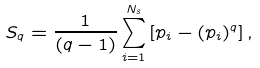<formula> <loc_0><loc_0><loc_500><loc_500>S _ { q } = \frac { 1 } { ( q - 1 ) } \sum _ { i = 1 } ^ { N _ { s } } \left [ p _ { i } - ( p _ { i } ) ^ { q } \right ] ,</formula> 